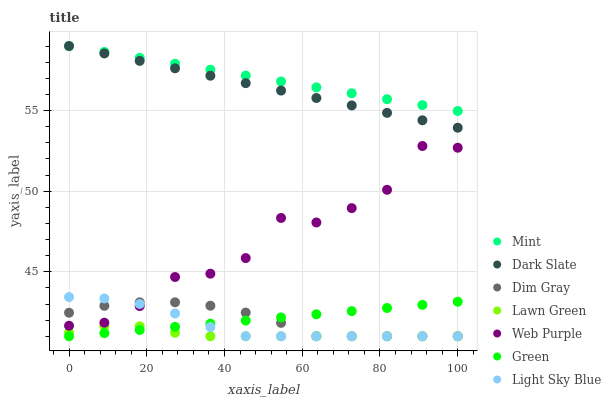Does Lawn Green have the minimum area under the curve?
Answer yes or no. Yes. Does Mint have the maximum area under the curve?
Answer yes or no. Yes. Does Dim Gray have the minimum area under the curve?
Answer yes or no. No. Does Dim Gray have the maximum area under the curve?
Answer yes or no. No. Is Green the smoothest?
Answer yes or no. Yes. Is Web Purple the roughest?
Answer yes or no. Yes. Is Dim Gray the smoothest?
Answer yes or no. No. Is Dim Gray the roughest?
Answer yes or no. No. Does Lawn Green have the lowest value?
Answer yes or no. Yes. Does Dark Slate have the lowest value?
Answer yes or no. No. Does Mint have the highest value?
Answer yes or no. Yes. Does Dim Gray have the highest value?
Answer yes or no. No. Is Lawn Green less than Mint?
Answer yes or no. Yes. Is Mint greater than Lawn Green?
Answer yes or no. Yes. Does Lawn Green intersect Light Sky Blue?
Answer yes or no. Yes. Is Lawn Green less than Light Sky Blue?
Answer yes or no. No. Is Lawn Green greater than Light Sky Blue?
Answer yes or no. No. Does Lawn Green intersect Mint?
Answer yes or no. No. 